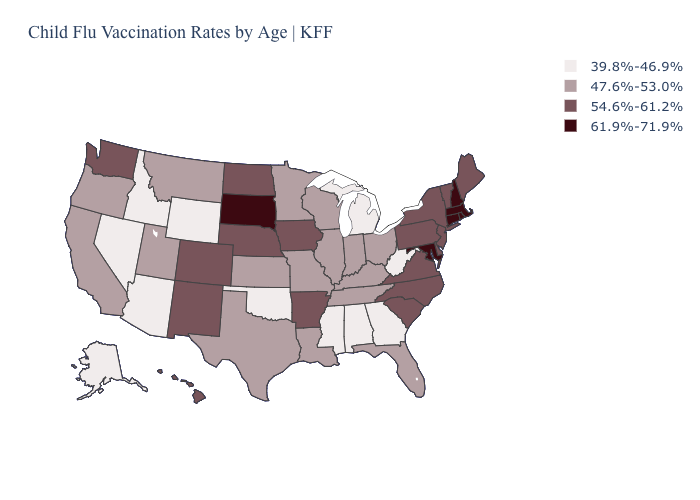Name the states that have a value in the range 61.9%-71.9%?
Write a very short answer. Connecticut, Maryland, Massachusetts, New Hampshire, Rhode Island, South Dakota. What is the value of Massachusetts?
Keep it brief. 61.9%-71.9%. Does the map have missing data?
Write a very short answer. No. What is the lowest value in the USA?
Answer briefly. 39.8%-46.9%. Does Iowa have a lower value than South Dakota?
Quick response, please. Yes. Name the states that have a value in the range 39.8%-46.9%?
Quick response, please. Alabama, Alaska, Arizona, Georgia, Idaho, Michigan, Mississippi, Nevada, Oklahoma, West Virginia, Wyoming. Is the legend a continuous bar?
Keep it brief. No. Name the states that have a value in the range 54.6%-61.2%?
Write a very short answer. Arkansas, Colorado, Delaware, Hawaii, Iowa, Maine, Nebraska, New Jersey, New Mexico, New York, North Carolina, North Dakota, Pennsylvania, South Carolina, Vermont, Virginia, Washington. Among the states that border Louisiana , does Mississippi have the lowest value?
Quick response, please. Yes. How many symbols are there in the legend?
Write a very short answer. 4. Which states have the lowest value in the USA?
Answer briefly. Alabama, Alaska, Arizona, Georgia, Idaho, Michigan, Mississippi, Nevada, Oklahoma, West Virginia, Wyoming. What is the highest value in the USA?
Quick response, please. 61.9%-71.9%. Does North Dakota have a higher value than Maryland?
Answer briefly. No. 